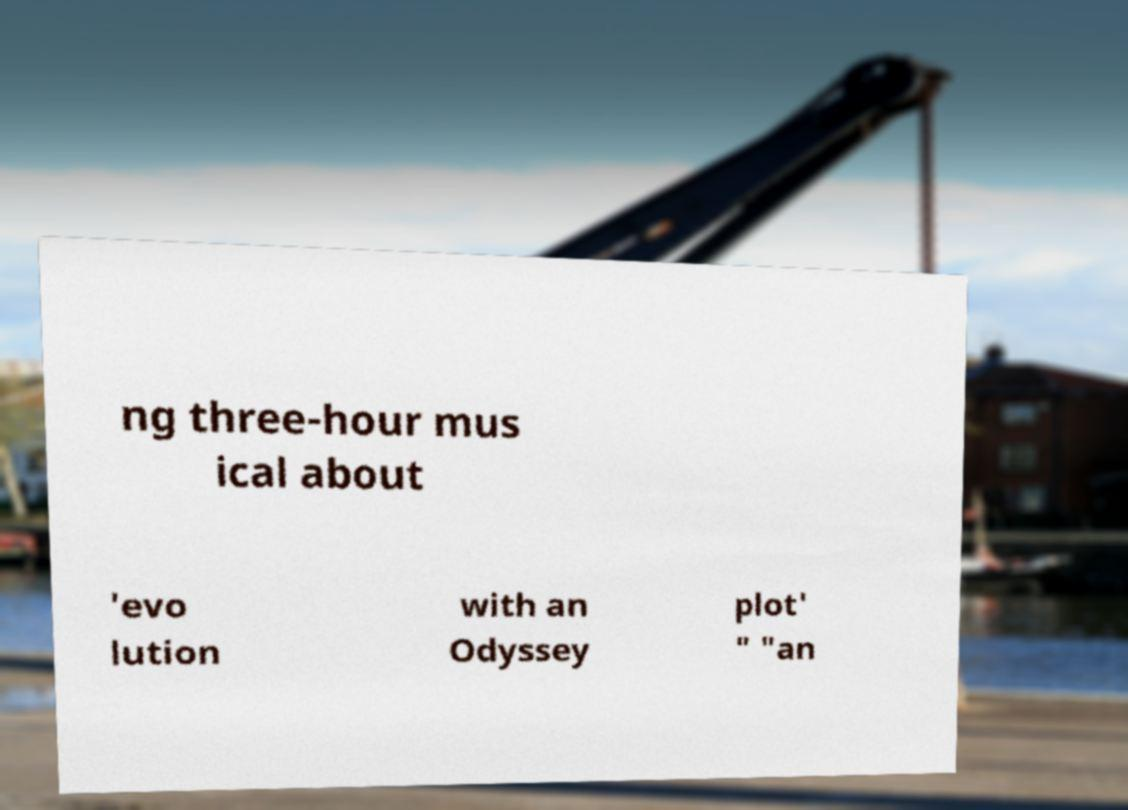What messages or text are displayed in this image? I need them in a readable, typed format. ng three-hour mus ical about 'evo lution with an Odyssey plot' " "an 